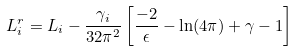Convert formula to latex. <formula><loc_0><loc_0><loc_500><loc_500>L _ { i } ^ { r } = L _ { i } - { \frac { \gamma _ { i } } { 3 2 \pi ^ { 2 } } } \left [ { \frac { - 2 } { \epsilon } } - \ln ( 4 \pi ) + \gamma - 1 \right ]</formula> 